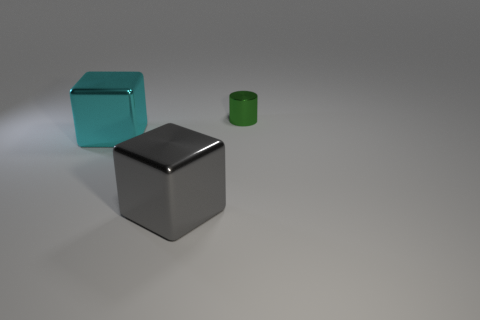Add 3 tiny cylinders. How many objects exist? 6 Subtract all cylinders. How many objects are left? 2 Subtract 0 yellow blocks. How many objects are left? 3 Subtract all large gray blocks. Subtract all small green cylinders. How many objects are left? 1 Add 2 large blocks. How many large blocks are left? 4 Add 1 matte spheres. How many matte spheres exist? 1 